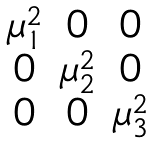Convert formula to latex. <formula><loc_0><loc_0><loc_500><loc_500>\begin{matrix} \mu _ { 1 } ^ { 2 } & 0 & 0 \\ 0 & \mu _ { 2 } ^ { 2 } & 0 \\ 0 & 0 & \mu _ { 3 } ^ { 2 } \\ \end{matrix}</formula> 